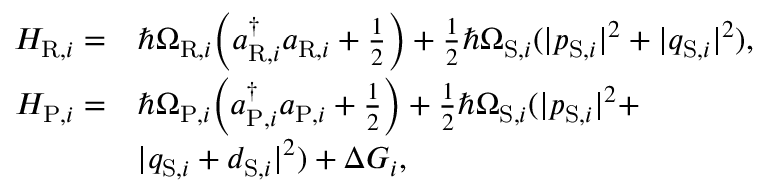<formula> <loc_0><loc_0><loc_500><loc_500>\begin{array} { r l r } { H _ { R , i } = } & { \hbar { \Omega } _ { R , i } \left ( a _ { R , i } ^ { \dagger } a _ { R , i } + \frac { 1 } { 2 } \right ) + \frac { 1 } { 2 } \hbar { \Omega } _ { S , i } ( | p _ { S , i } | ^ { 2 } + | q _ { S , i } | ^ { 2 } ) , } & \\ { H _ { P , i } = } & { \hbar { \Omega } _ { P , i } \left ( a _ { P , i } ^ { \dagger } a _ { P , i } + \frac { 1 } { 2 } \right ) + \frac { 1 } { 2 } \hbar { \Omega } _ { S , i } ( | p _ { S , i } | ^ { 2 } + } & \\ & { | q _ { S , i } + d _ { S , i } | ^ { 2 } ) + \Delta G _ { i } , } & \end{array}</formula> 